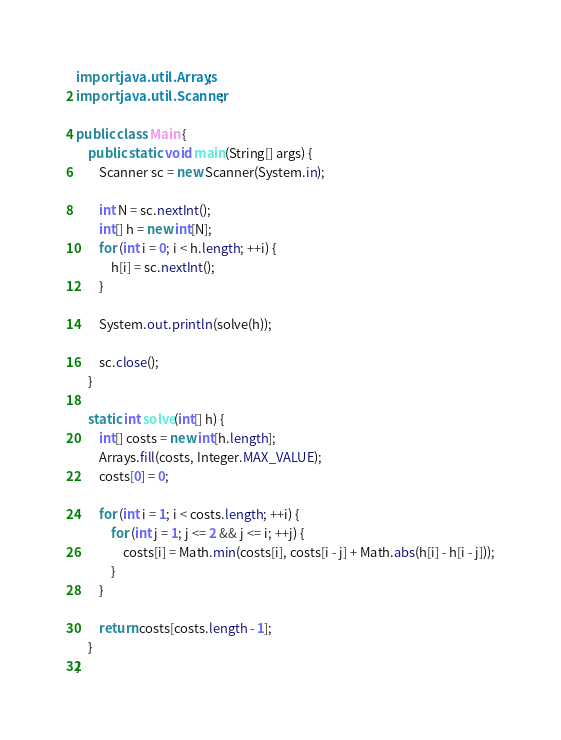<code> <loc_0><loc_0><loc_500><loc_500><_Java_>import java.util.Arrays;
import java.util.Scanner;

public class Main {
    public static void main(String[] args) {
        Scanner sc = new Scanner(System.in);

        int N = sc.nextInt();
        int[] h = new int[N];
        for (int i = 0; i < h.length; ++i) {
            h[i] = sc.nextInt();
        }

        System.out.println(solve(h));

        sc.close();
    }

    static int solve(int[] h) {
        int[] costs = new int[h.length];
        Arrays.fill(costs, Integer.MAX_VALUE);
        costs[0] = 0;

        for (int i = 1; i < costs.length; ++i) {
            for (int j = 1; j <= 2 && j <= i; ++j) {
                costs[i] = Math.min(costs[i], costs[i - j] + Math.abs(h[i] - h[i - j]));
            }
        }

        return costs[costs.length - 1];
    }
}</code> 